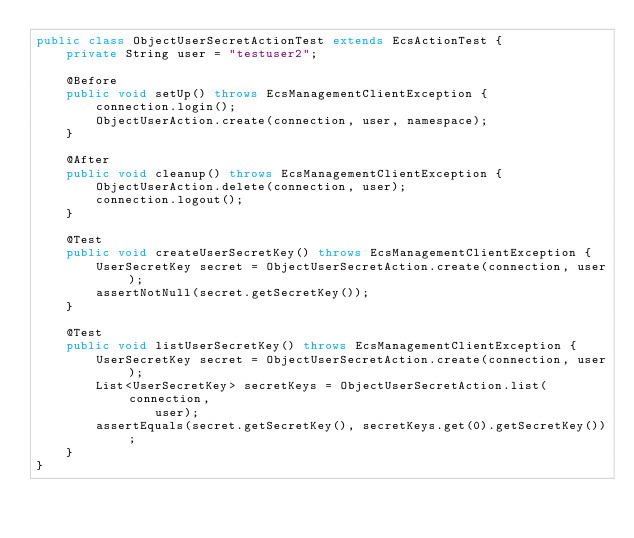<code> <loc_0><loc_0><loc_500><loc_500><_Java_>public class ObjectUserSecretActionTest extends EcsActionTest {
    private String user = "testuser2";

    @Before
    public void setUp() throws EcsManagementClientException {
        connection.login();
        ObjectUserAction.create(connection, user, namespace);
    }

    @After
    public void cleanup() throws EcsManagementClientException {
        ObjectUserAction.delete(connection, user);
        connection.logout();
    }

    @Test
    public void createUserSecretKey() throws EcsManagementClientException {
        UserSecretKey secret = ObjectUserSecretAction.create(connection, user);
        assertNotNull(secret.getSecretKey());
    }

    @Test
    public void listUserSecretKey() throws EcsManagementClientException {
        UserSecretKey secret = ObjectUserSecretAction.create(connection, user);
        List<UserSecretKey> secretKeys = ObjectUserSecretAction.list(connection,
                user);
        assertEquals(secret.getSecretKey(), secretKeys.get(0).getSecretKey());
    }
}
</code> 